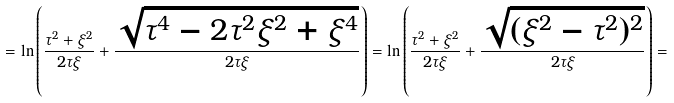<formula> <loc_0><loc_0><loc_500><loc_500>= \ln \left ( \frac { \tau ^ { 2 } + \xi ^ { 2 } } { 2 \tau \xi } + \frac { \sqrt { \tau ^ { 4 } - 2 \tau ^ { 2 } \xi ^ { 2 } + \xi ^ { 4 } } } { 2 \tau \xi } \right ) = \ln \left ( \frac { \tau ^ { 2 } + \xi ^ { 2 } } { 2 \tau \xi } + \frac { \sqrt { ( \xi ^ { 2 } - \tau ^ { 2 } ) ^ { 2 } } } { 2 \tau \xi } \right ) =</formula> 